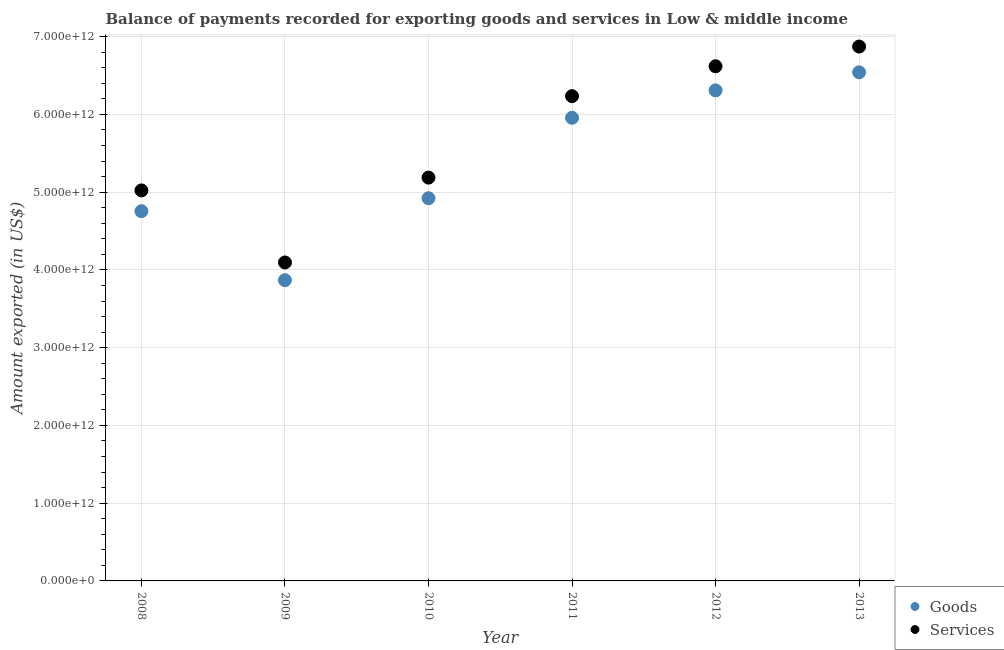How many different coloured dotlines are there?
Offer a terse response. 2. What is the amount of services exported in 2012?
Give a very brief answer. 6.62e+12. Across all years, what is the maximum amount of services exported?
Offer a very short reply. 6.87e+12. Across all years, what is the minimum amount of services exported?
Ensure brevity in your answer.  4.10e+12. In which year was the amount of goods exported minimum?
Offer a terse response. 2009. What is the total amount of services exported in the graph?
Your answer should be compact. 3.40e+13. What is the difference between the amount of goods exported in 2012 and that in 2013?
Provide a succinct answer. -2.32e+11. What is the difference between the amount of services exported in 2011 and the amount of goods exported in 2008?
Keep it short and to the point. 1.48e+12. What is the average amount of goods exported per year?
Provide a short and direct response. 5.39e+12. In the year 2012, what is the difference between the amount of goods exported and amount of services exported?
Your response must be concise. -3.10e+11. What is the ratio of the amount of services exported in 2008 to that in 2011?
Offer a terse response. 0.81. Is the difference between the amount of goods exported in 2008 and 2012 greater than the difference between the amount of services exported in 2008 and 2012?
Keep it short and to the point. Yes. What is the difference between the highest and the second highest amount of services exported?
Give a very brief answer. 2.53e+11. What is the difference between the highest and the lowest amount of services exported?
Your answer should be compact. 2.78e+12. Is the amount of services exported strictly greater than the amount of goods exported over the years?
Your answer should be compact. Yes. Is the amount of goods exported strictly less than the amount of services exported over the years?
Provide a short and direct response. Yes. How many dotlines are there?
Your answer should be very brief. 2. What is the difference between two consecutive major ticks on the Y-axis?
Your answer should be very brief. 1.00e+12. Are the values on the major ticks of Y-axis written in scientific E-notation?
Give a very brief answer. Yes. Does the graph contain grids?
Your response must be concise. Yes. How many legend labels are there?
Your answer should be compact. 2. How are the legend labels stacked?
Keep it short and to the point. Vertical. What is the title of the graph?
Your response must be concise. Balance of payments recorded for exporting goods and services in Low & middle income. Does "Non-residents" appear as one of the legend labels in the graph?
Offer a terse response. No. What is the label or title of the Y-axis?
Your response must be concise. Amount exported (in US$). What is the Amount exported (in US$) in Goods in 2008?
Your response must be concise. 4.76e+12. What is the Amount exported (in US$) of Services in 2008?
Offer a very short reply. 5.02e+12. What is the Amount exported (in US$) in Goods in 2009?
Your answer should be very brief. 3.87e+12. What is the Amount exported (in US$) of Services in 2009?
Provide a short and direct response. 4.10e+12. What is the Amount exported (in US$) of Goods in 2010?
Give a very brief answer. 4.92e+12. What is the Amount exported (in US$) of Services in 2010?
Provide a succinct answer. 5.19e+12. What is the Amount exported (in US$) of Goods in 2011?
Your response must be concise. 5.96e+12. What is the Amount exported (in US$) of Services in 2011?
Keep it short and to the point. 6.23e+12. What is the Amount exported (in US$) in Goods in 2012?
Make the answer very short. 6.31e+12. What is the Amount exported (in US$) of Services in 2012?
Offer a very short reply. 6.62e+12. What is the Amount exported (in US$) of Goods in 2013?
Your answer should be compact. 6.54e+12. What is the Amount exported (in US$) in Services in 2013?
Make the answer very short. 6.87e+12. Across all years, what is the maximum Amount exported (in US$) of Goods?
Your answer should be very brief. 6.54e+12. Across all years, what is the maximum Amount exported (in US$) in Services?
Keep it short and to the point. 6.87e+12. Across all years, what is the minimum Amount exported (in US$) in Goods?
Give a very brief answer. 3.87e+12. Across all years, what is the minimum Amount exported (in US$) in Services?
Your response must be concise. 4.10e+12. What is the total Amount exported (in US$) in Goods in the graph?
Your response must be concise. 3.24e+13. What is the total Amount exported (in US$) in Services in the graph?
Ensure brevity in your answer.  3.40e+13. What is the difference between the Amount exported (in US$) in Goods in 2008 and that in 2009?
Your answer should be compact. 8.87e+11. What is the difference between the Amount exported (in US$) in Services in 2008 and that in 2009?
Your answer should be very brief. 9.27e+11. What is the difference between the Amount exported (in US$) of Goods in 2008 and that in 2010?
Give a very brief answer. -1.67e+11. What is the difference between the Amount exported (in US$) in Services in 2008 and that in 2010?
Keep it short and to the point. -1.65e+11. What is the difference between the Amount exported (in US$) of Goods in 2008 and that in 2011?
Provide a short and direct response. -1.20e+12. What is the difference between the Amount exported (in US$) of Services in 2008 and that in 2011?
Your answer should be compact. -1.21e+12. What is the difference between the Amount exported (in US$) of Goods in 2008 and that in 2012?
Keep it short and to the point. -1.55e+12. What is the difference between the Amount exported (in US$) in Services in 2008 and that in 2012?
Your answer should be compact. -1.60e+12. What is the difference between the Amount exported (in US$) of Goods in 2008 and that in 2013?
Offer a very short reply. -1.79e+12. What is the difference between the Amount exported (in US$) of Services in 2008 and that in 2013?
Your answer should be compact. -1.85e+12. What is the difference between the Amount exported (in US$) of Goods in 2009 and that in 2010?
Keep it short and to the point. -1.05e+12. What is the difference between the Amount exported (in US$) of Services in 2009 and that in 2010?
Your response must be concise. -1.09e+12. What is the difference between the Amount exported (in US$) in Goods in 2009 and that in 2011?
Offer a terse response. -2.09e+12. What is the difference between the Amount exported (in US$) of Services in 2009 and that in 2011?
Keep it short and to the point. -2.14e+12. What is the difference between the Amount exported (in US$) in Goods in 2009 and that in 2012?
Ensure brevity in your answer.  -2.44e+12. What is the difference between the Amount exported (in US$) of Services in 2009 and that in 2012?
Give a very brief answer. -2.52e+12. What is the difference between the Amount exported (in US$) in Goods in 2009 and that in 2013?
Offer a terse response. -2.67e+12. What is the difference between the Amount exported (in US$) of Services in 2009 and that in 2013?
Keep it short and to the point. -2.78e+12. What is the difference between the Amount exported (in US$) in Goods in 2010 and that in 2011?
Your answer should be very brief. -1.03e+12. What is the difference between the Amount exported (in US$) in Services in 2010 and that in 2011?
Give a very brief answer. -1.05e+12. What is the difference between the Amount exported (in US$) of Goods in 2010 and that in 2012?
Your answer should be compact. -1.39e+12. What is the difference between the Amount exported (in US$) in Services in 2010 and that in 2012?
Offer a very short reply. -1.43e+12. What is the difference between the Amount exported (in US$) of Goods in 2010 and that in 2013?
Ensure brevity in your answer.  -1.62e+12. What is the difference between the Amount exported (in US$) of Services in 2010 and that in 2013?
Provide a succinct answer. -1.69e+12. What is the difference between the Amount exported (in US$) in Goods in 2011 and that in 2012?
Your answer should be very brief. -3.53e+11. What is the difference between the Amount exported (in US$) in Services in 2011 and that in 2012?
Make the answer very short. -3.84e+11. What is the difference between the Amount exported (in US$) in Goods in 2011 and that in 2013?
Offer a very short reply. -5.84e+11. What is the difference between the Amount exported (in US$) in Services in 2011 and that in 2013?
Your response must be concise. -6.38e+11. What is the difference between the Amount exported (in US$) of Goods in 2012 and that in 2013?
Your answer should be very brief. -2.32e+11. What is the difference between the Amount exported (in US$) of Services in 2012 and that in 2013?
Provide a succinct answer. -2.53e+11. What is the difference between the Amount exported (in US$) in Goods in 2008 and the Amount exported (in US$) in Services in 2009?
Give a very brief answer. 6.59e+11. What is the difference between the Amount exported (in US$) in Goods in 2008 and the Amount exported (in US$) in Services in 2010?
Your answer should be compact. -4.32e+11. What is the difference between the Amount exported (in US$) of Goods in 2008 and the Amount exported (in US$) of Services in 2011?
Your answer should be very brief. -1.48e+12. What is the difference between the Amount exported (in US$) of Goods in 2008 and the Amount exported (in US$) of Services in 2012?
Your answer should be compact. -1.86e+12. What is the difference between the Amount exported (in US$) of Goods in 2008 and the Amount exported (in US$) of Services in 2013?
Make the answer very short. -2.12e+12. What is the difference between the Amount exported (in US$) of Goods in 2009 and the Amount exported (in US$) of Services in 2010?
Provide a short and direct response. -1.32e+12. What is the difference between the Amount exported (in US$) of Goods in 2009 and the Amount exported (in US$) of Services in 2011?
Your answer should be very brief. -2.37e+12. What is the difference between the Amount exported (in US$) in Goods in 2009 and the Amount exported (in US$) in Services in 2012?
Your response must be concise. -2.75e+12. What is the difference between the Amount exported (in US$) of Goods in 2009 and the Amount exported (in US$) of Services in 2013?
Ensure brevity in your answer.  -3.00e+12. What is the difference between the Amount exported (in US$) of Goods in 2010 and the Amount exported (in US$) of Services in 2011?
Offer a terse response. -1.31e+12. What is the difference between the Amount exported (in US$) of Goods in 2010 and the Amount exported (in US$) of Services in 2012?
Give a very brief answer. -1.70e+12. What is the difference between the Amount exported (in US$) of Goods in 2010 and the Amount exported (in US$) of Services in 2013?
Give a very brief answer. -1.95e+12. What is the difference between the Amount exported (in US$) in Goods in 2011 and the Amount exported (in US$) in Services in 2012?
Provide a short and direct response. -6.63e+11. What is the difference between the Amount exported (in US$) of Goods in 2011 and the Amount exported (in US$) of Services in 2013?
Make the answer very short. -9.16e+11. What is the difference between the Amount exported (in US$) of Goods in 2012 and the Amount exported (in US$) of Services in 2013?
Your response must be concise. -5.63e+11. What is the average Amount exported (in US$) in Goods per year?
Provide a short and direct response. 5.39e+12. What is the average Amount exported (in US$) in Services per year?
Provide a succinct answer. 5.67e+12. In the year 2008, what is the difference between the Amount exported (in US$) in Goods and Amount exported (in US$) in Services?
Make the answer very short. -2.67e+11. In the year 2009, what is the difference between the Amount exported (in US$) in Goods and Amount exported (in US$) in Services?
Provide a short and direct response. -2.28e+11. In the year 2010, what is the difference between the Amount exported (in US$) in Goods and Amount exported (in US$) in Services?
Give a very brief answer. -2.65e+11. In the year 2011, what is the difference between the Amount exported (in US$) of Goods and Amount exported (in US$) of Services?
Offer a very short reply. -2.78e+11. In the year 2012, what is the difference between the Amount exported (in US$) of Goods and Amount exported (in US$) of Services?
Keep it short and to the point. -3.10e+11. In the year 2013, what is the difference between the Amount exported (in US$) of Goods and Amount exported (in US$) of Services?
Give a very brief answer. -3.32e+11. What is the ratio of the Amount exported (in US$) in Goods in 2008 to that in 2009?
Provide a short and direct response. 1.23. What is the ratio of the Amount exported (in US$) of Services in 2008 to that in 2009?
Make the answer very short. 1.23. What is the ratio of the Amount exported (in US$) of Goods in 2008 to that in 2010?
Ensure brevity in your answer.  0.97. What is the ratio of the Amount exported (in US$) in Services in 2008 to that in 2010?
Provide a succinct answer. 0.97. What is the ratio of the Amount exported (in US$) of Goods in 2008 to that in 2011?
Provide a succinct answer. 0.8. What is the ratio of the Amount exported (in US$) of Services in 2008 to that in 2011?
Offer a terse response. 0.81. What is the ratio of the Amount exported (in US$) of Goods in 2008 to that in 2012?
Keep it short and to the point. 0.75. What is the ratio of the Amount exported (in US$) in Services in 2008 to that in 2012?
Provide a succinct answer. 0.76. What is the ratio of the Amount exported (in US$) in Goods in 2008 to that in 2013?
Keep it short and to the point. 0.73. What is the ratio of the Amount exported (in US$) of Services in 2008 to that in 2013?
Offer a very short reply. 0.73. What is the ratio of the Amount exported (in US$) of Goods in 2009 to that in 2010?
Provide a succinct answer. 0.79. What is the ratio of the Amount exported (in US$) of Services in 2009 to that in 2010?
Provide a short and direct response. 0.79. What is the ratio of the Amount exported (in US$) of Goods in 2009 to that in 2011?
Your answer should be compact. 0.65. What is the ratio of the Amount exported (in US$) in Services in 2009 to that in 2011?
Provide a short and direct response. 0.66. What is the ratio of the Amount exported (in US$) in Goods in 2009 to that in 2012?
Your answer should be very brief. 0.61. What is the ratio of the Amount exported (in US$) of Services in 2009 to that in 2012?
Provide a succinct answer. 0.62. What is the ratio of the Amount exported (in US$) of Goods in 2009 to that in 2013?
Your answer should be compact. 0.59. What is the ratio of the Amount exported (in US$) of Services in 2009 to that in 2013?
Your answer should be very brief. 0.6. What is the ratio of the Amount exported (in US$) of Goods in 2010 to that in 2011?
Offer a terse response. 0.83. What is the ratio of the Amount exported (in US$) in Services in 2010 to that in 2011?
Give a very brief answer. 0.83. What is the ratio of the Amount exported (in US$) of Goods in 2010 to that in 2012?
Give a very brief answer. 0.78. What is the ratio of the Amount exported (in US$) of Services in 2010 to that in 2012?
Keep it short and to the point. 0.78. What is the ratio of the Amount exported (in US$) of Goods in 2010 to that in 2013?
Offer a very short reply. 0.75. What is the ratio of the Amount exported (in US$) of Services in 2010 to that in 2013?
Ensure brevity in your answer.  0.75. What is the ratio of the Amount exported (in US$) in Goods in 2011 to that in 2012?
Give a very brief answer. 0.94. What is the ratio of the Amount exported (in US$) of Services in 2011 to that in 2012?
Your answer should be very brief. 0.94. What is the ratio of the Amount exported (in US$) of Goods in 2011 to that in 2013?
Give a very brief answer. 0.91. What is the ratio of the Amount exported (in US$) in Services in 2011 to that in 2013?
Keep it short and to the point. 0.91. What is the ratio of the Amount exported (in US$) in Goods in 2012 to that in 2013?
Offer a terse response. 0.96. What is the ratio of the Amount exported (in US$) in Services in 2012 to that in 2013?
Your answer should be very brief. 0.96. What is the difference between the highest and the second highest Amount exported (in US$) of Goods?
Make the answer very short. 2.32e+11. What is the difference between the highest and the second highest Amount exported (in US$) of Services?
Your answer should be compact. 2.53e+11. What is the difference between the highest and the lowest Amount exported (in US$) in Goods?
Your response must be concise. 2.67e+12. What is the difference between the highest and the lowest Amount exported (in US$) in Services?
Provide a short and direct response. 2.78e+12. 